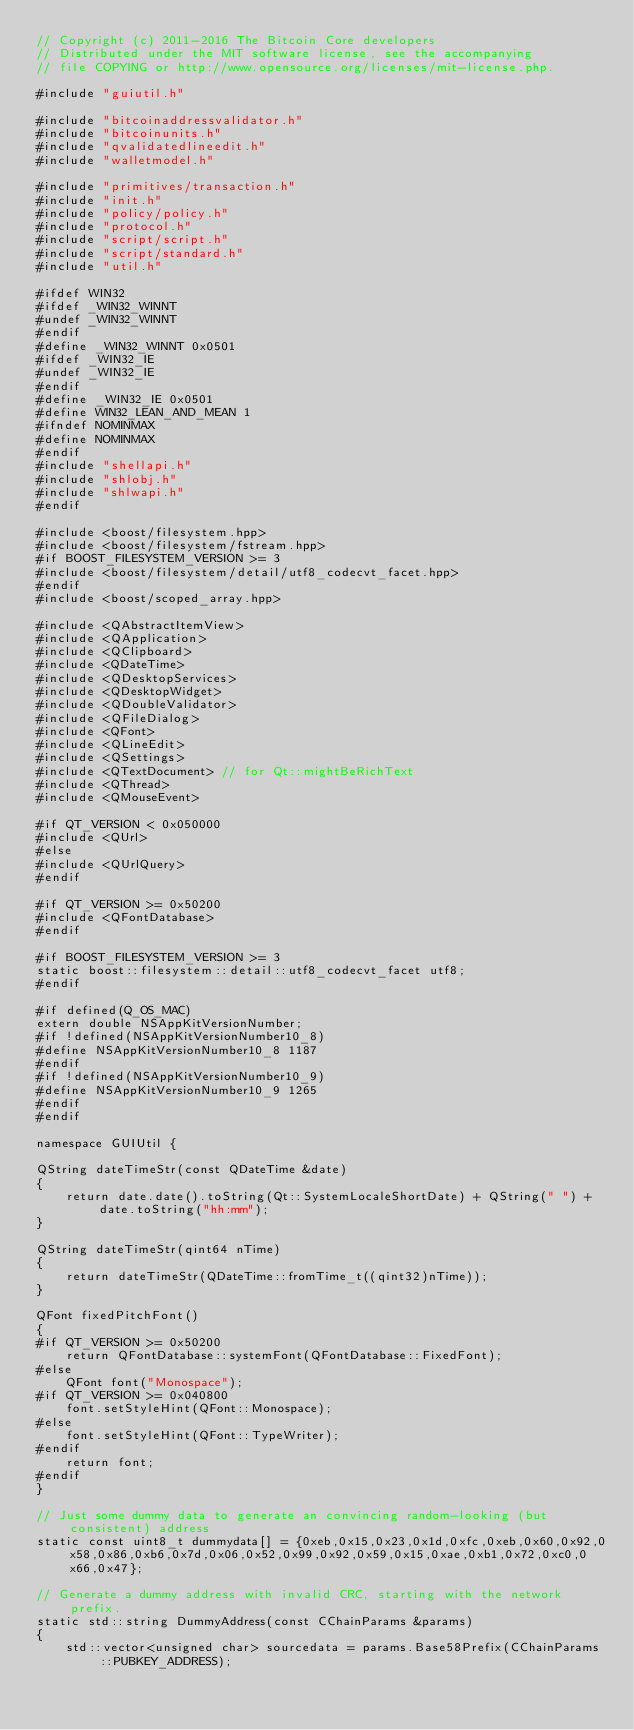<code> <loc_0><loc_0><loc_500><loc_500><_C++_>// Copyright (c) 2011-2016 The Bitcoin Core developers
// Distributed under the MIT software license, see the accompanying
// file COPYING or http://www.opensource.org/licenses/mit-license.php.

#include "guiutil.h"

#include "bitcoinaddressvalidator.h"
#include "bitcoinunits.h"
#include "qvalidatedlineedit.h"
#include "walletmodel.h"

#include "primitives/transaction.h"
#include "init.h"
#include "policy/policy.h"
#include "protocol.h"
#include "script/script.h"
#include "script/standard.h"
#include "util.h"

#ifdef WIN32
#ifdef _WIN32_WINNT
#undef _WIN32_WINNT
#endif
#define _WIN32_WINNT 0x0501
#ifdef _WIN32_IE
#undef _WIN32_IE
#endif
#define _WIN32_IE 0x0501
#define WIN32_LEAN_AND_MEAN 1
#ifndef NOMINMAX
#define NOMINMAX
#endif
#include "shellapi.h"
#include "shlobj.h"
#include "shlwapi.h"
#endif

#include <boost/filesystem.hpp>
#include <boost/filesystem/fstream.hpp>
#if BOOST_FILESYSTEM_VERSION >= 3
#include <boost/filesystem/detail/utf8_codecvt_facet.hpp>
#endif
#include <boost/scoped_array.hpp>

#include <QAbstractItemView>
#include <QApplication>
#include <QClipboard>
#include <QDateTime>
#include <QDesktopServices>
#include <QDesktopWidget>
#include <QDoubleValidator>
#include <QFileDialog>
#include <QFont>
#include <QLineEdit>
#include <QSettings>
#include <QTextDocument> // for Qt::mightBeRichText
#include <QThread>
#include <QMouseEvent>

#if QT_VERSION < 0x050000
#include <QUrl>
#else
#include <QUrlQuery>
#endif

#if QT_VERSION >= 0x50200
#include <QFontDatabase>
#endif

#if BOOST_FILESYSTEM_VERSION >= 3
static boost::filesystem::detail::utf8_codecvt_facet utf8;
#endif

#if defined(Q_OS_MAC)
extern double NSAppKitVersionNumber;
#if !defined(NSAppKitVersionNumber10_8)
#define NSAppKitVersionNumber10_8 1187
#endif
#if !defined(NSAppKitVersionNumber10_9)
#define NSAppKitVersionNumber10_9 1265
#endif
#endif

namespace GUIUtil {

QString dateTimeStr(const QDateTime &date)
{
    return date.date().toString(Qt::SystemLocaleShortDate) + QString(" ") + date.toString("hh:mm");
}

QString dateTimeStr(qint64 nTime)
{
    return dateTimeStr(QDateTime::fromTime_t((qint32)nTime));
}

QFont fixedPitchFont()
{
#if QT_VERSION >= 0x50200
    return QFontDatabase::systemFont(QFontDatabase::FixedFont);
#else
    QFont font("Monospace");
#if QT_VERSION >= 0x040800
    font.setStyleHint(QFont::Monospace);
#else
    font.setStyleHint(QFont::TypeWriter);
#endif
    return font;
#endif
}

// Just some dummy data to generate an convincing random-looking (but consistent) address
static const uint8_t dummydata[] = {0xeb,0x15,0x23,0x1d,0xfc,0xeb,0x60,0x92,0x58,0x86,0xb6,0x7d,0x06,0x52,0x99,0x92,0x59,0x15,0xae,0xb1,0x72,0xc0,0x66,0x47};

// Generate a dummy address with invalid CRC, starting with the network prefix.
static std::string DummyAddress(const CChainParams &params)
{
    std::vector<unsigned char> sourcedata = params.Base58Prefix(CChainParams::PUBKEY_ADDRESS);</code> 